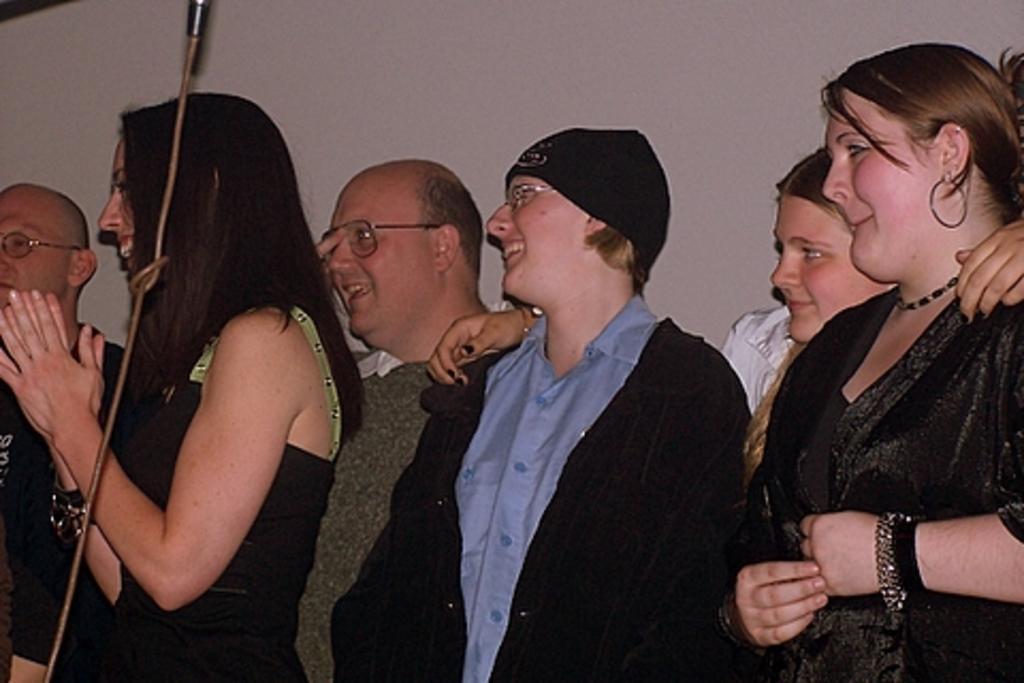Please provide a concise description of this image. In this image I can see number of persons are standing and smiling. I can see few of them are wearing spectacles and I can see the white colored background. 